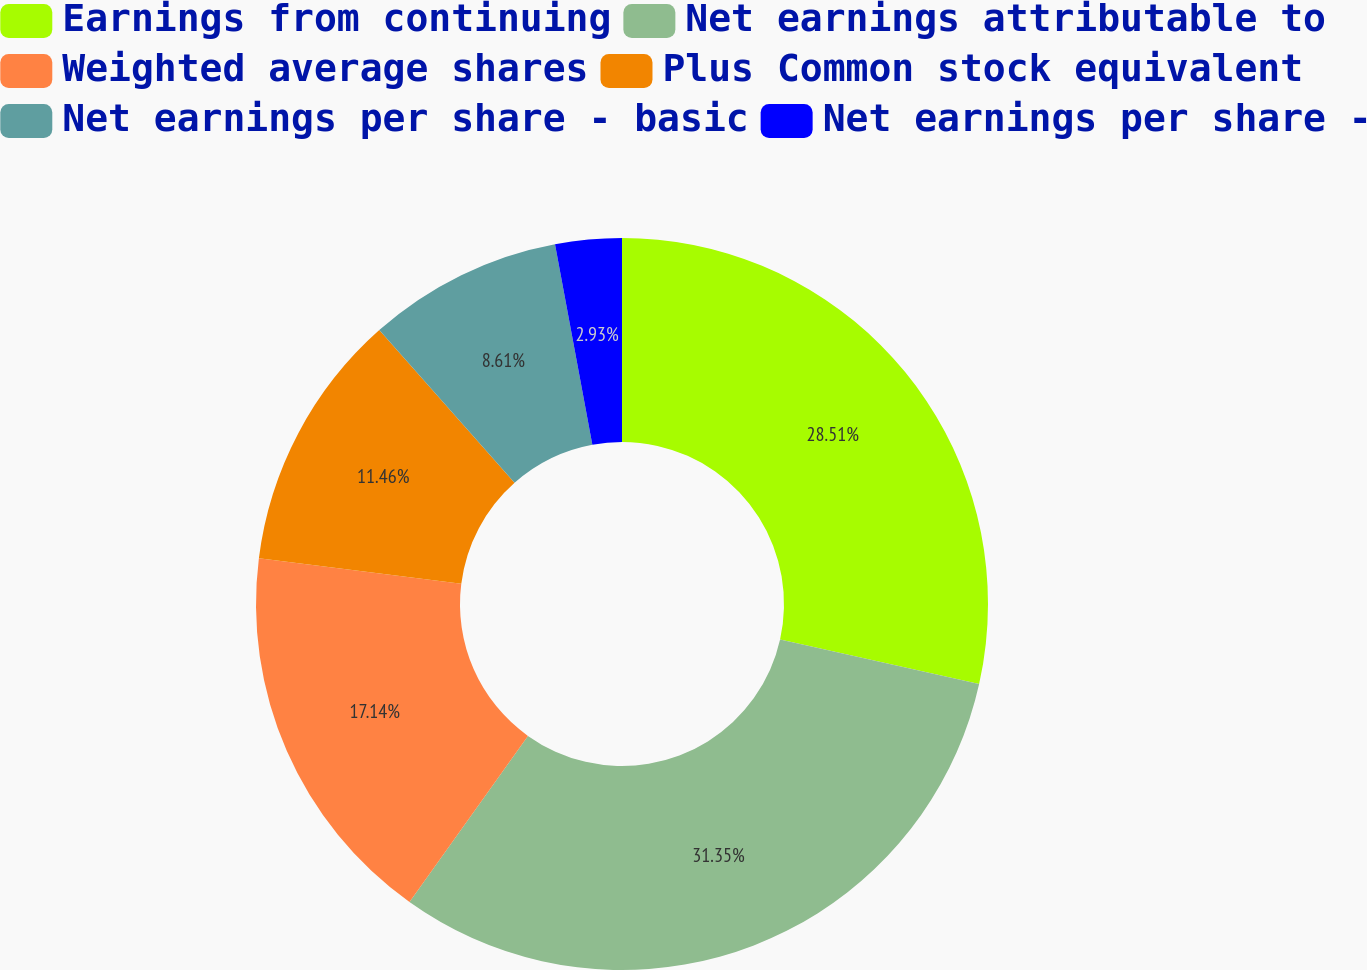Convert chart to OTSL. <chart><loc_0><loc_0><loc_500><loc_500><pie_chart><fcel>Earnings from continuing<fcel>Net earnings attributable to<fcel>Weighted average shares<fcel>Plus Common stock equivalent<fcel>Net earnings per share - basic<fcel>Net earnings per share -<nl><fcel>28.51%<fcel>31.35%<fcel>17.14%<fcel>11.46%<fcel>8.61%<fcel>2.93%<nl></chart> 